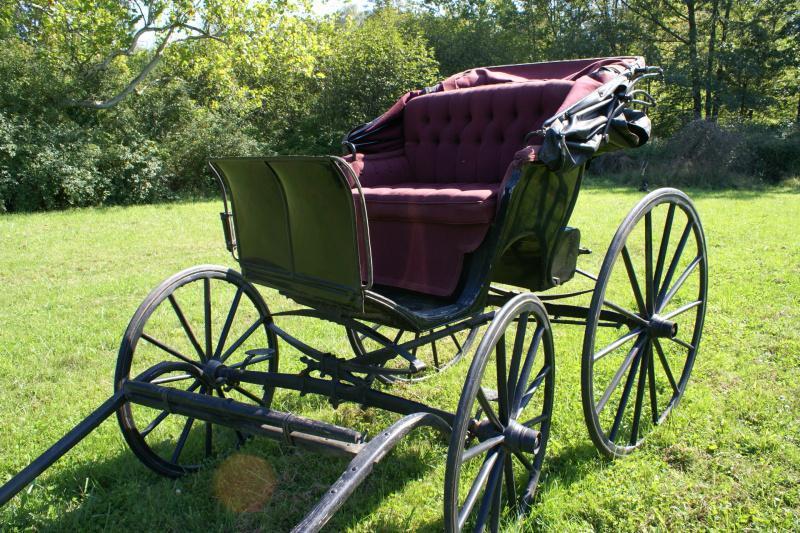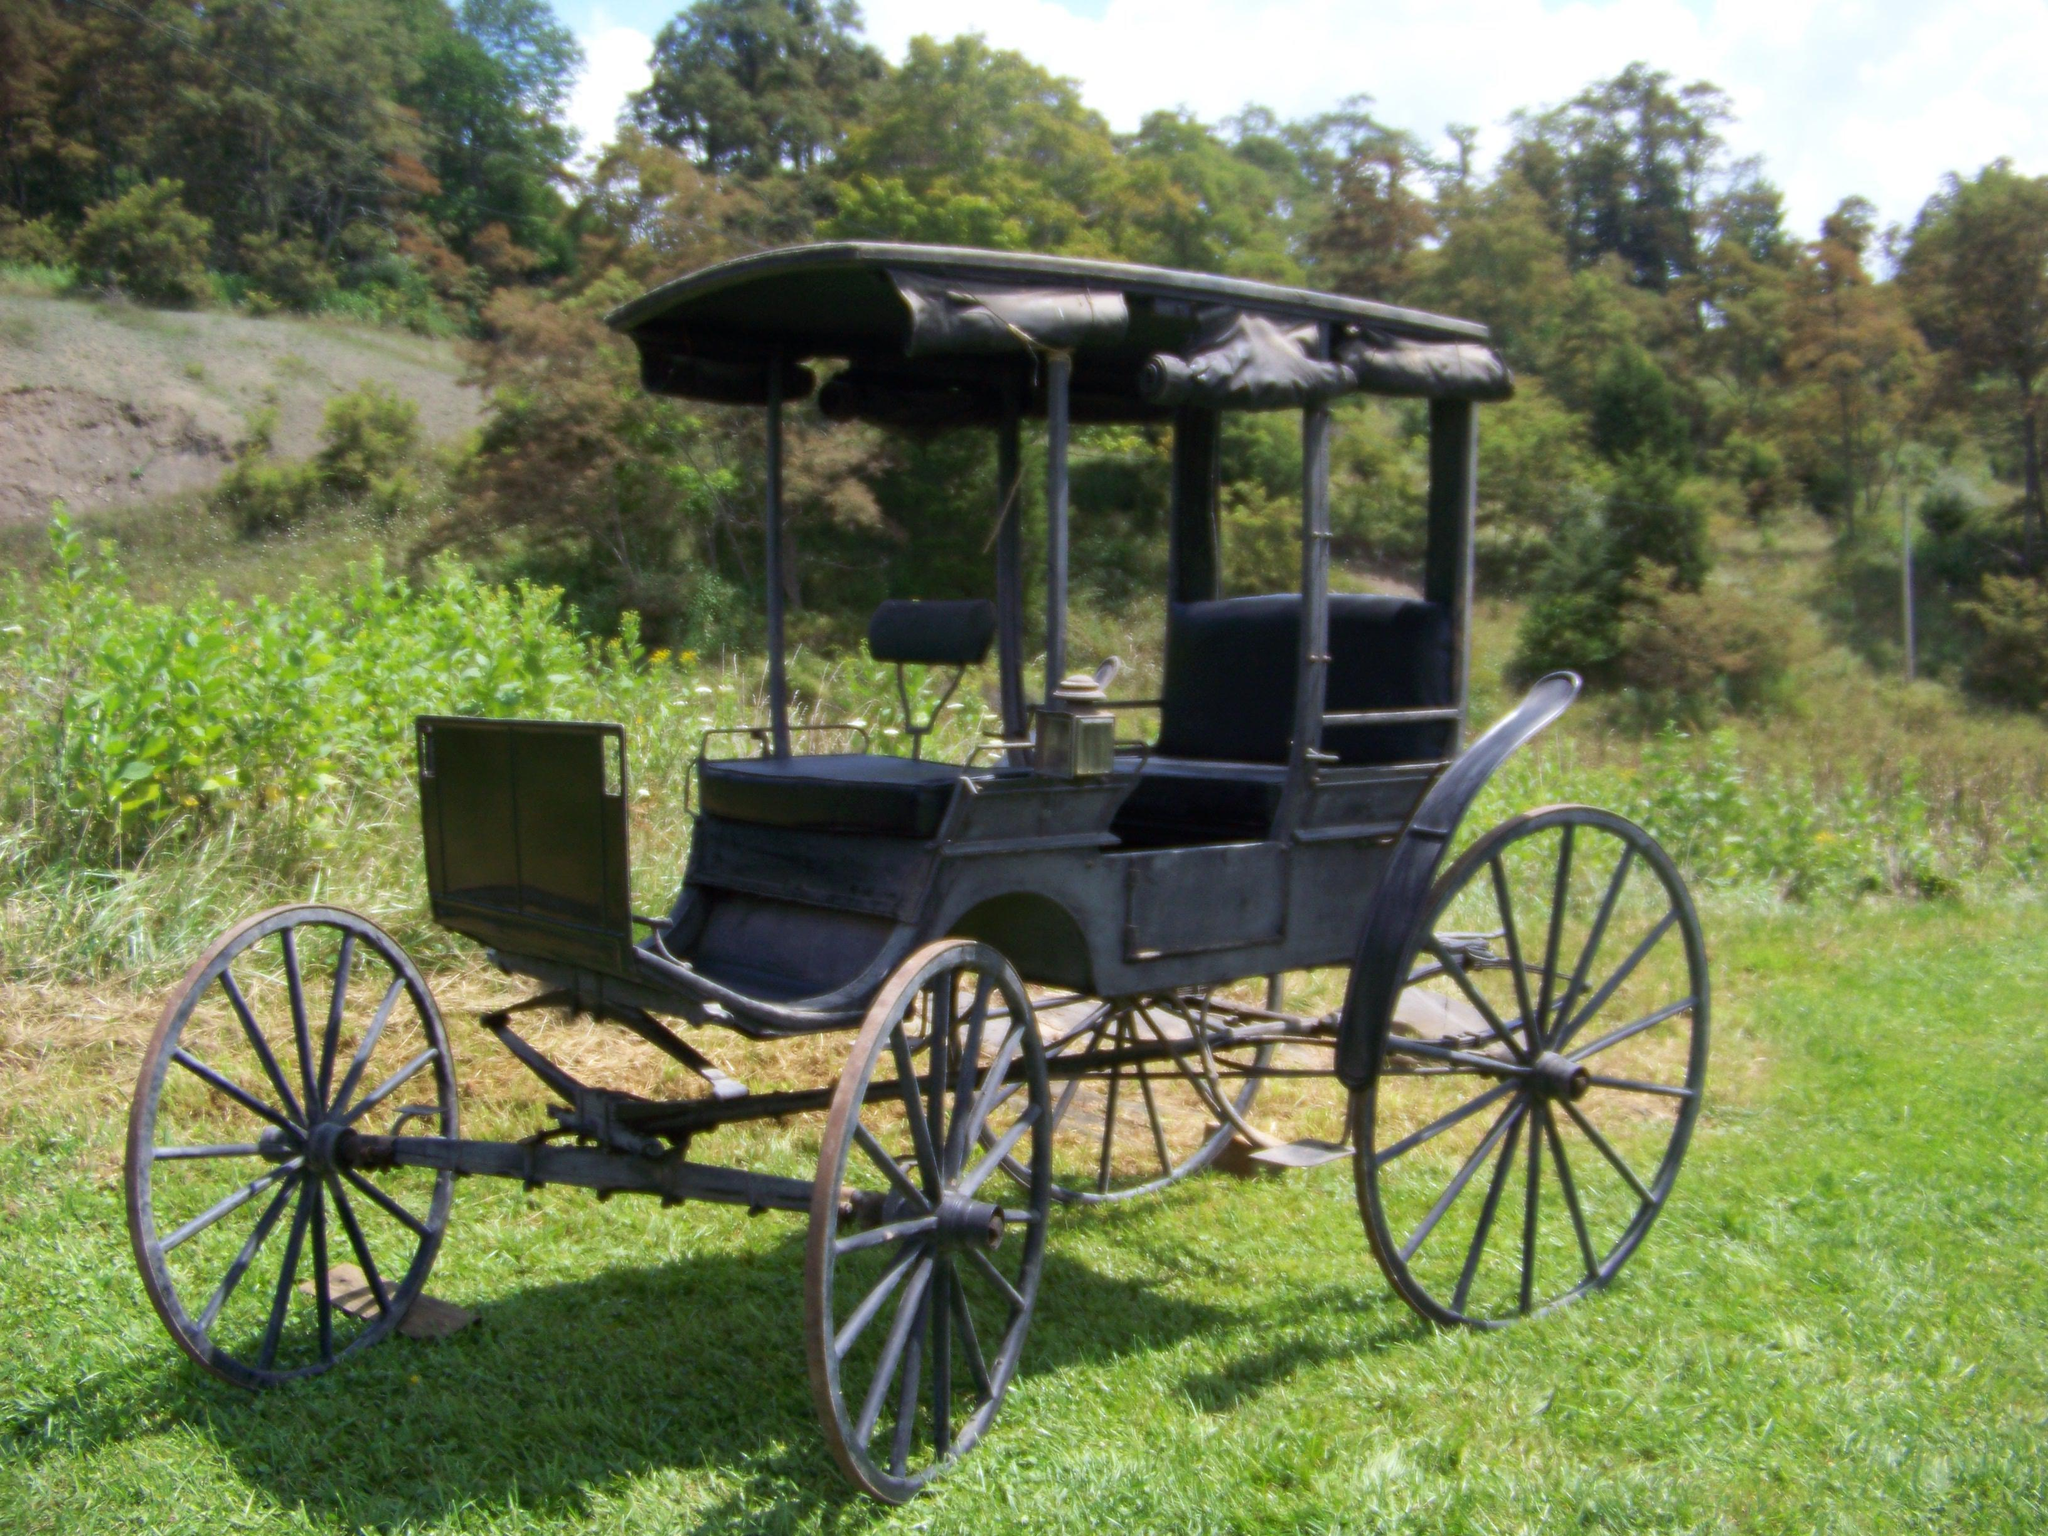The first image is the image on the left, the second image is the image on the right. For the images shown, is this caption "An image shows a wagon with violet interior and a dark top over it." true? Answer yes or no. No. The first image is the image on the left, the second image is the image on the right. Given the left and right images, does the statement "At least one of the carriages has wheels with red spokes." hold true? Answer yes or no. No. 